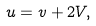Convert formula to latex. <formula><loc_0><loc_0><loc_500><loc_500>u = v + 2 V ,</formula> 